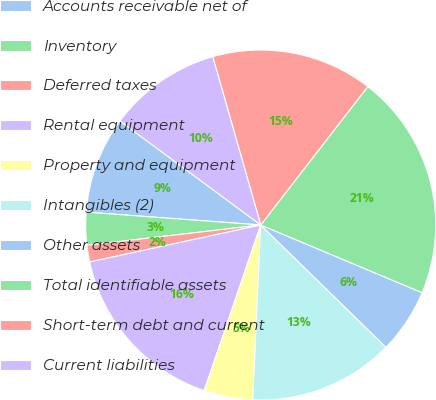<chart> <loc_0><loc_0><loc_500><loc_500><pie_chart><fcel>Accounts receivable net of<fcel>Inventory<fcel>Deferred taxes<fcel>Rental equipment<fcel>Property and equipment<fcel>Intangibles (2)<fcel>Other assets<fcel>Total identifiable assets<fcel>Short-term debt and current<fcel>Current liabilities<nl><fcel>8.96%<fcel>3.02%<fcel>1.54%<fcel>16.38%<fcel>4.51%<fcel>13.41%<fcel>5.99%<fcel>20.84%<fcel>14.9%<fcel>10.45%<nl></chart> 